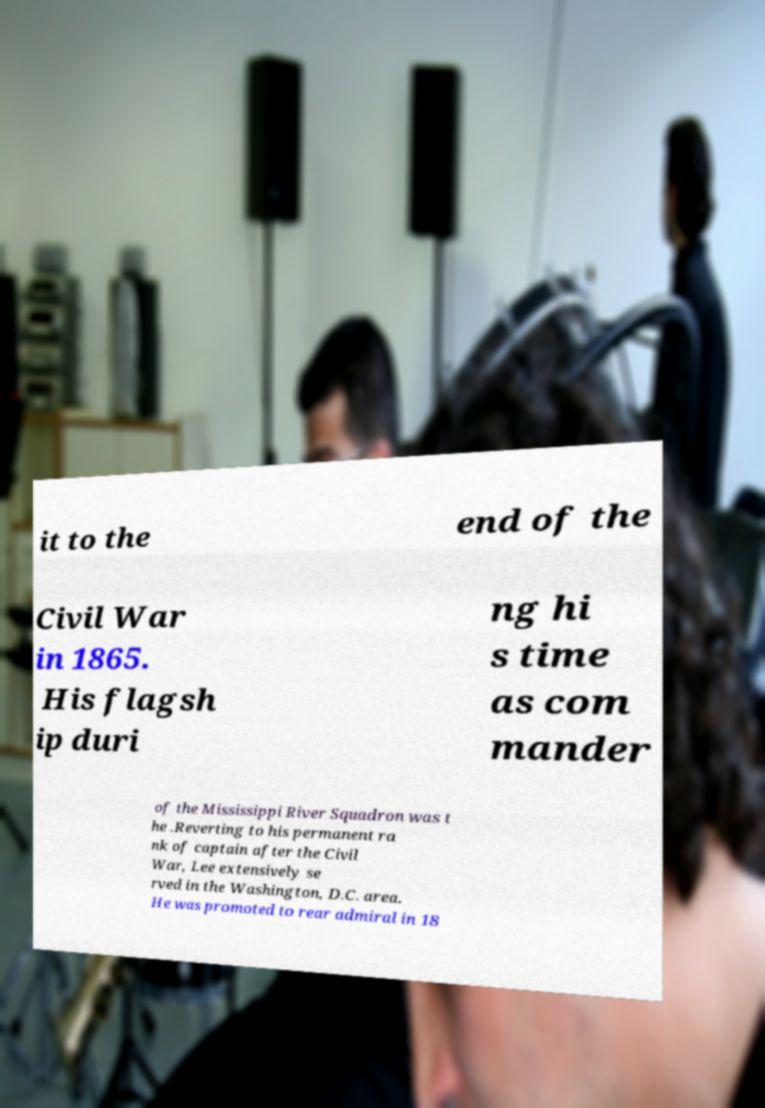I need the written content from this picture converted into text. Can you do that? it to the end of the Civil War in 1865. His flagsh ip duri ng hi s time as com mander of the Mississippi River Squadron was t he .Reverting to his permanent ra nk of captain after the Civil War, Lee extensively se rved in the Washington, D.C. area. He was promoted to rear admiral in 18 